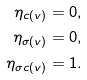Convert formula to latex. <formula><loc_0><loc_0><loc_500><loc_500>\eta _ { c ( v ) } & = 0 , \\ \eta _ { \sigma ( v ) } & = 0 , \\ \eta _ { \sigma c ( v ) } & = 1 . \\</formula> 